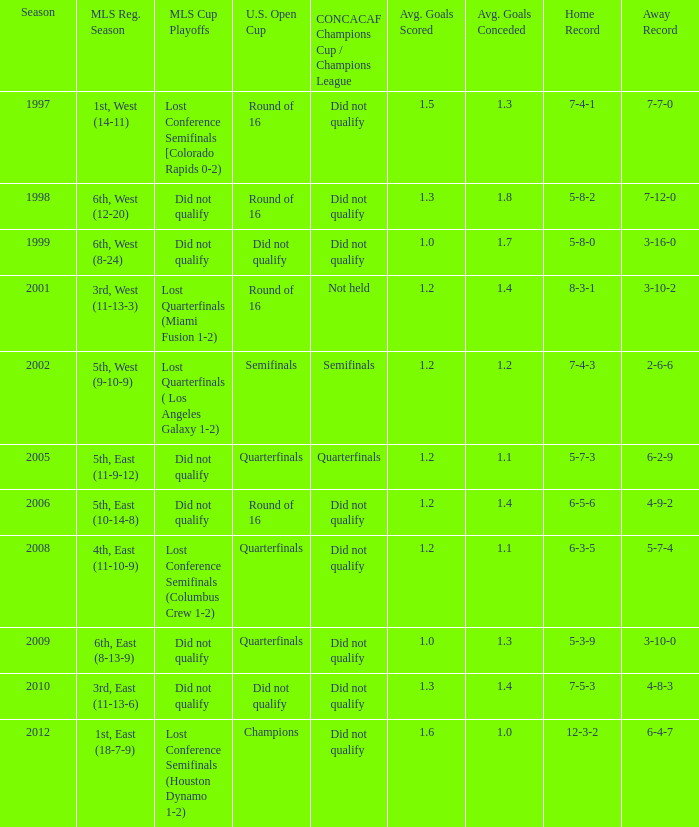What were the placements of the team in regular season when they reached quarterfinals in the U.S. Open Cup but did not qualify for the Concaf Champions Cup? 4th, East (11-10-9), 6th, East (8-13-9). 